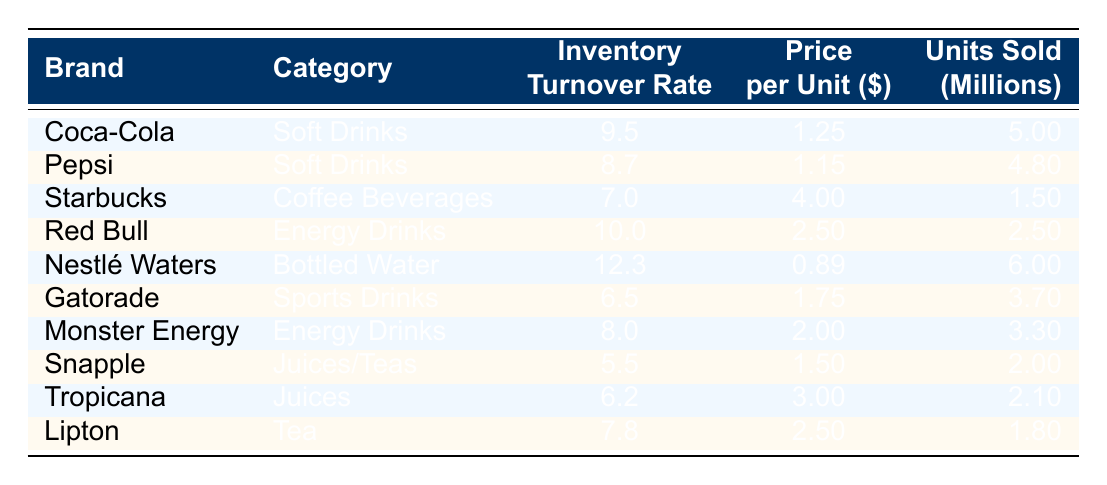What is the inventory turnover rate for Coca-Cola? The table shows the brand Coca-Cola, under the column labeled "Inventory Turnover Rate," which indicates its specific turnover rate as 9.5.
Answer: 9.5 Which brand has the highest price per unit? By examining the "Price per Unit" column in the table, it can be noted that Starbucks has the highest price per unit at 4.00.
Answer: Starbucks How many units did Nestlé Waters sell? Looking at the "Units Sold" column for Nestlé Waters, we can see that the value listed there is 6,000,000 units sold.
Answer: 6,000,000 What is the average inventory turnover rate for Energy Drinks? The brands in the Energy Drinks category are Red Bull and Monster Energy. Their rates are 10.0 and 8.0, respectively. To find the average, we calculate (10.0 + 8.0) / 2 = 9.0.
Answer: 9.0 Is the inventory turnover rate for Gatorade higher than that of Tropicana? The inventory turnover rate for Gatorade is 6.5, while for Tropicana it is 6.2. Since 6.5 is greater than 6.2, the statement is true.
Answer: Yes Which brand sold the least number of units? The brand with the least units sold is Snapple, which has a value of 2,000,000 units sold found in the "Units Sold" column.
Answer: Snapple What is the difference in inventory turnover rate between Coca-Cola and Pepsi? The inventory turnover rate for Coca-Cola is 9.5 and for Pepsi, it is 8.7. The difference can be calculated as 9.5 - 8.7 = 0.8.
Answer: 0.8 What percentage of units sold is attributed to Nestlé Waters compared to the total units sold of all brands? First, sum all units sold: 5,000,000 + 4,800,000 + 1,500,000 + 2,500,000 + 6,000,000 + 3,700,000 + 3,300,000 + 2,000,000 + 2,100,000 + 1,800,000 = 33,900,000. Next, find Nestlé Waters' contribution: (6,000,000 / 33,900,000) * 100 = 17.7%.
Answer: 17.7% Which beverages category has the highest average number of units sold? To find the average units sold by category, we calculate the totals for each category: Soft Drinks (5.0 + 4.8)/2 = 4.9, Coffee Beverages (1.5), Energy Drinks (2.5 + 3.3)/2 = 2.9, Bottled Water (6.0), Sports Drinks (3.7), Juices (2.1), and Tea (1.8). The highest average is for Bottled Water at 6.0.
Answer: Bottled Water 